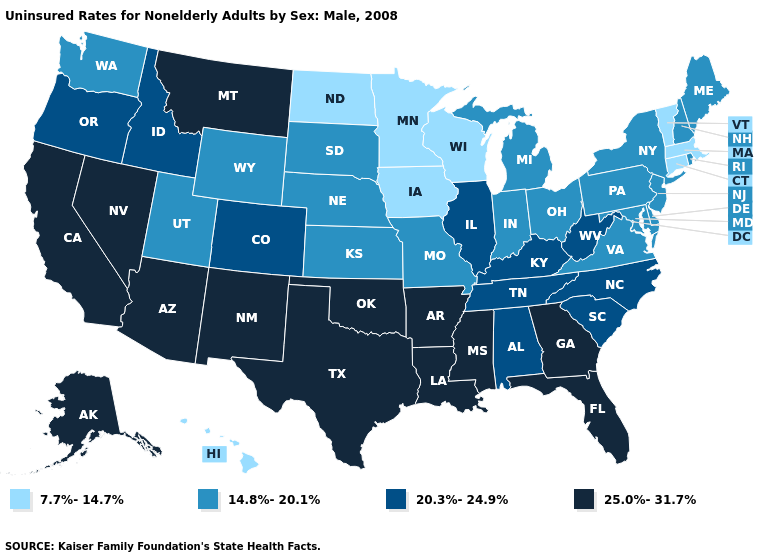Which states have the lowest value in the USA?
Quick response, please. Connecticut, Hawaii, Iowa, Massachusetts, Minnesota, North Dakota, Vermont, Wisconsin. Which states have the lowest value in the South?
Be succinct. Delaware, Maryland, Virginia. What is the value of Hawaii?
Be succinct. 7.7%-14.7%. What is the value of Missouri?
Be succinct. 14.8%-20.1%. Name the states that have a value in the range 20.3%-24.9%?
Concise answer only. Alabama, Colorado, Idaho, Illinois, Kentucky, North Carolina, Oregon, South Carolina, Tennessee, West Virginia. What is the value of New York?
Answer briefly. 14.8%-20.1%. Which states have the lowest value in the USA?
Keep it brief. Connecticut, Hawaii, Iowa, Massachusetts, Minnesota, North Dakota, Vermont, Wisconsin. What is the value of Montana?
Short answer required. 25.0%-31.7%. What is the value of Virginia?
Quick response, please. 14.8%-20.1%. Does West Virginia have the lowest value in the South?
Write a very short answer. No. What is the highest value in the Northeast ?
Be succinct. 14.8%-20.1%. Which states have the highest value in the USA?
Quick response, please. Alaska, Arizona, Arkansas, California, Florida, Georgia, Louisiana, Mississippi, Montana, Nevada, New Mexico, Oklahoma, Texas. Does the first symbol in the legend represent the smallest category?
Keep it brief. Yes. What is the value of Alabama?
Write a very short answer. 20.3%-24.9%. What is the value of South Dakota?
Keep it brief. 14.8%-20.1%. 